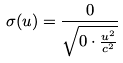<formula> <loc_0><loc_0><loc_500><loc_500>\sigma ( u ) = \frac { 0 } { \sqrt { 0 \cdot \frac { u ^ { 2 } } { c ^ { 2 } } } }</formula> 